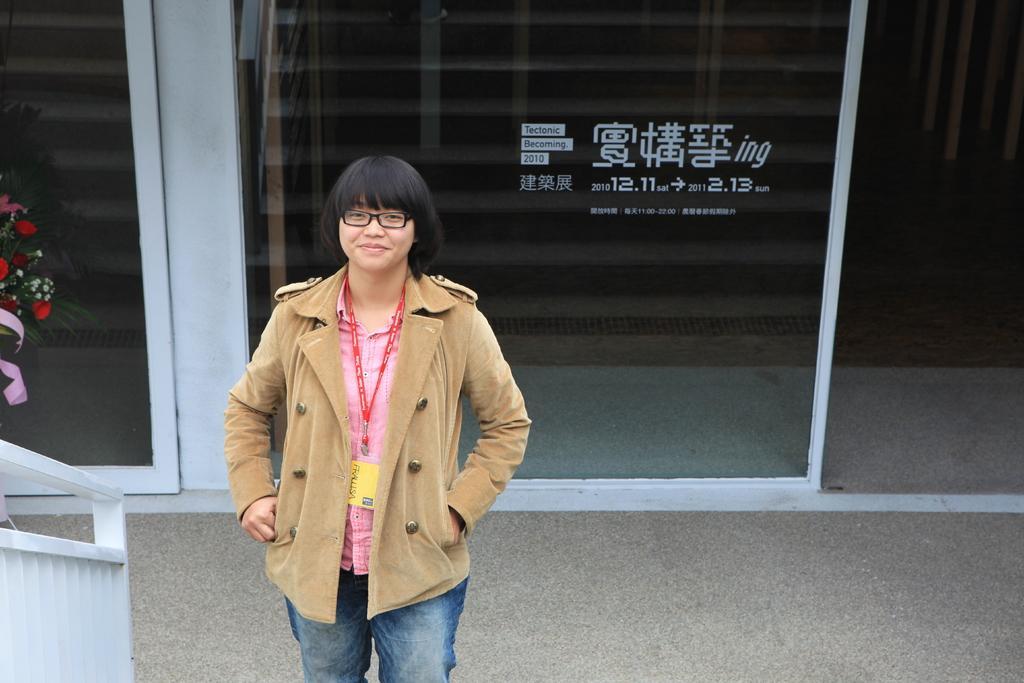Could you give a brief overview of what you see in this image? This image consists of a woman wearing a brown coat and blue jeans. At the bottom, there is a floor. On the left, there is a hand railing. In the background, we can see glass doors. On the left, we can see the red roses. 